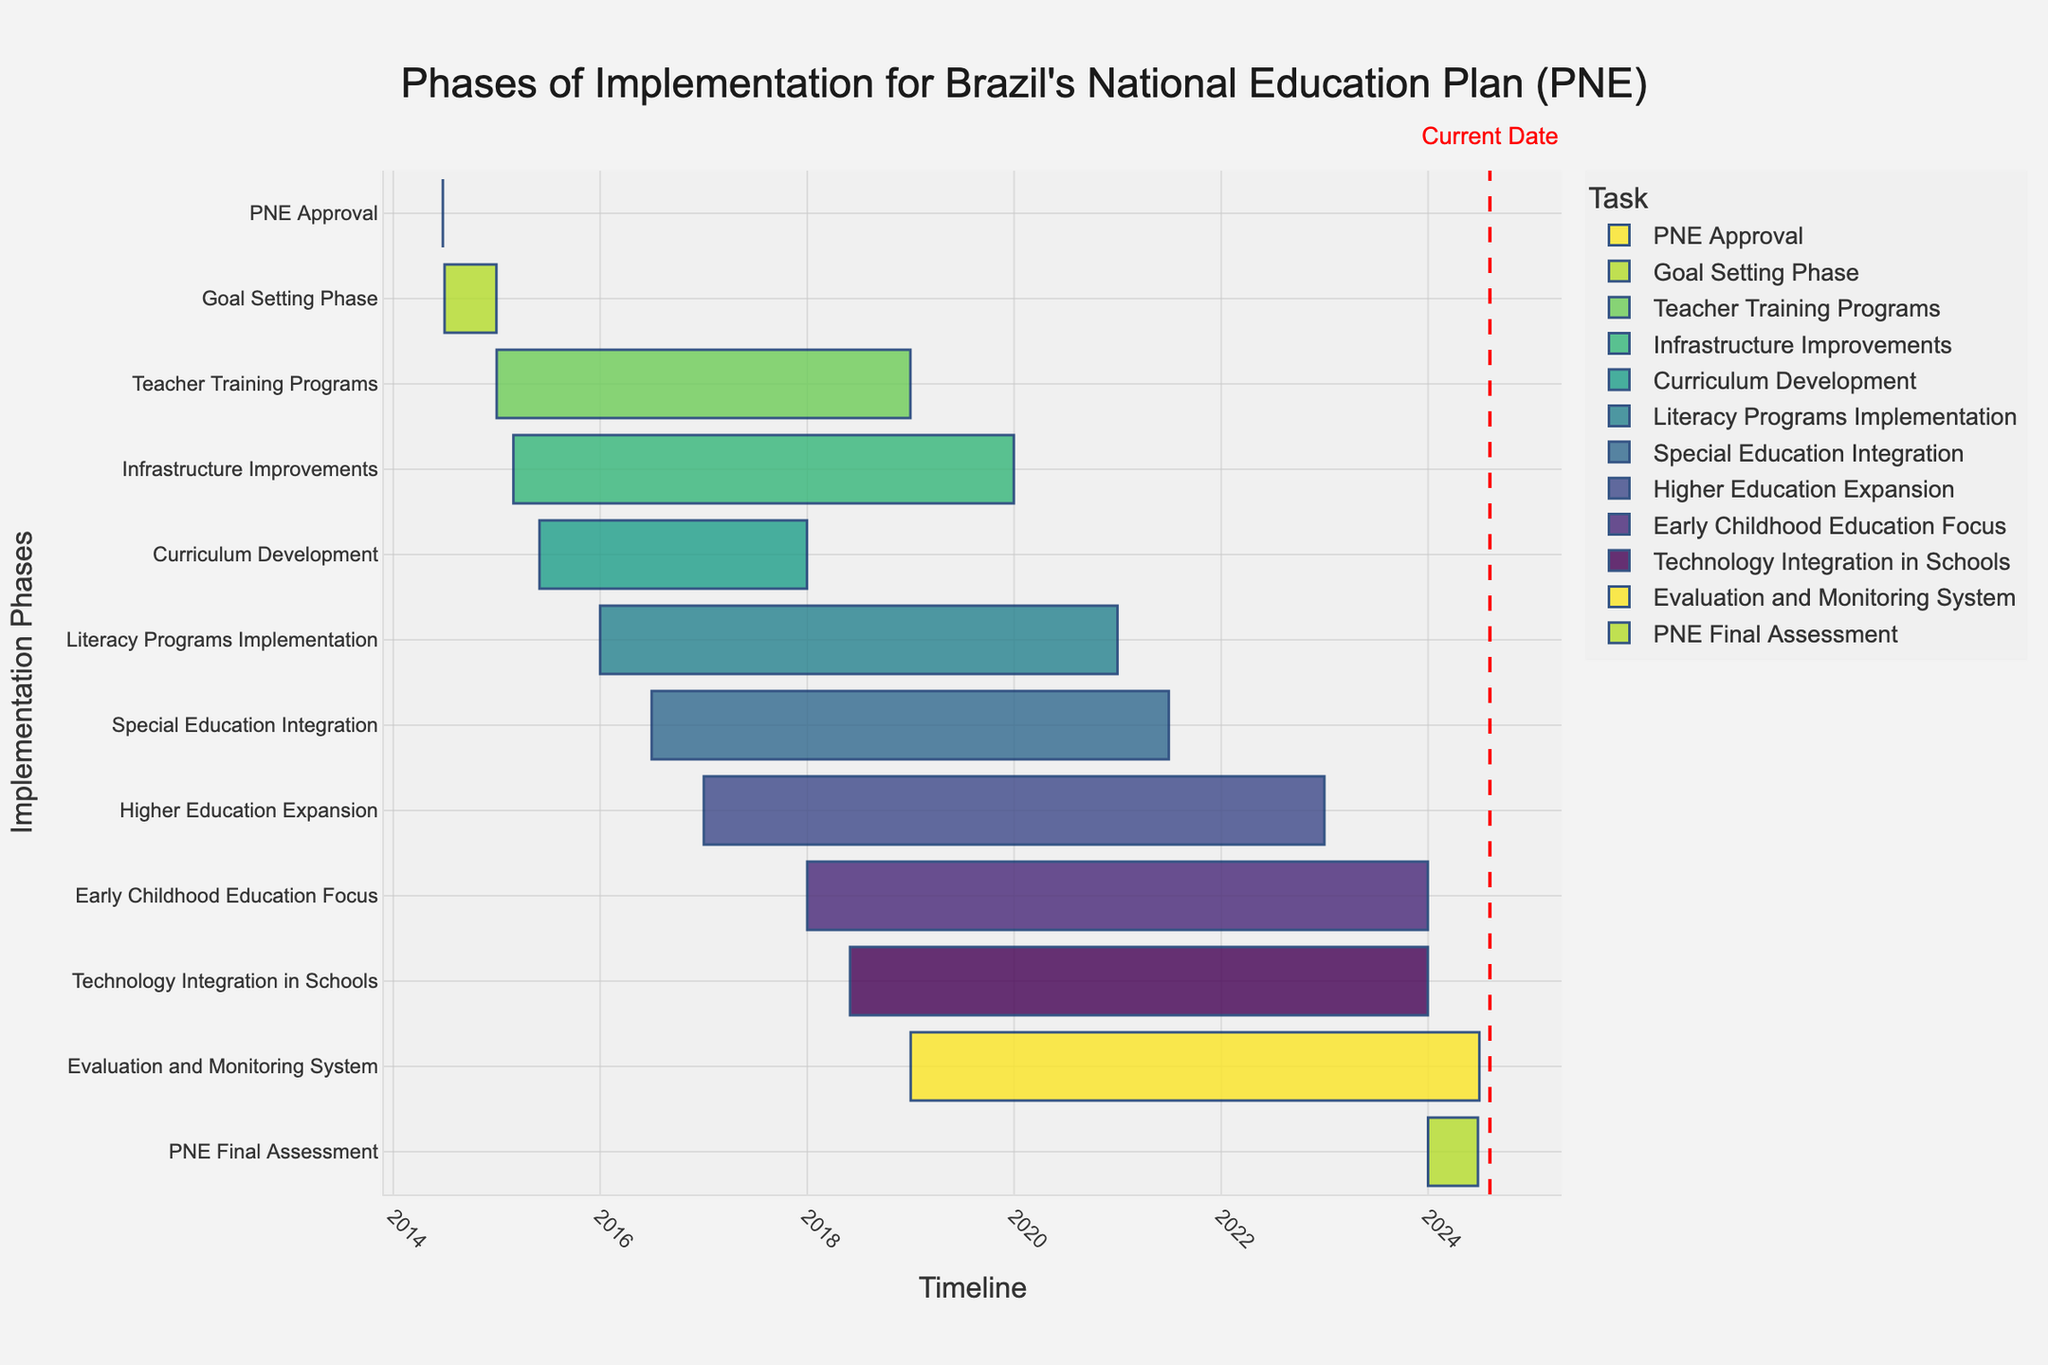Which phase starts first after the PNE approval? According to the timeline, the first phase that starts after the PNE approval is the "Goal Setting Phase," which begins on July 1, 2014.
Answer: Goal Setting Phase What is the duration of the Teacher Training Programs phase? The Teacher Training Programs phase starts on January 1, 2015, and ends on December 31, 2018. To find the duration, count the number of years from the start date to the end date. There are 4 years total.
Answer: 4 years Which phase ends last among all the implementation phases? To determine this, look for the phase that has the latest end date. The last phase to end is the "Evaluation and Monitoring System," which ends on June 30, 2024.
Answer: Evaluation and Monitoring System What is the overlap period between the Infrastructure Improvements and the Literacy Programs Implementation phases? The Infrastructure Improvements phase runs from March 1, 2015, to December 31, 2019, while the Literacy Programs Implementation phase runs from January 1, 2016, to December 31, 2020. The overlap period starts from January 1, 2016, and ends on December 31, 2019.
Answer: January 1, 2016, to December 31, 2019 How long does the Curriculum Development phase last? The Curriculum Development phase starts on June 1, 2015, and ends on December 31, 2017. To find the duration, count the number of years and months between these dates. It lasts for 2 years and 7 months.
Answer: 2 years and 7 months Between which years do most phases overlap? To determine this, examine the start and end dates of all phases. Most phases overlap between 2018 and 2019, as more than five phases are active during this period.
Answer: 2018-2019 Which phase is immediately after the Curriculum Development phase in terms of starting time? The phase that starts immediately after Curriculum Development (June 1, 2015 - December 31, 2017) is the Literacy Programs Implementation phase, starting on January 1, 2016. Although there is an overlap, Literacy Programs Implementation starts while Curriculum Development is still ongoing.
Answer: Literacy Programs Implementation Compare the starting time of Higher Education Expansion and Technology Integration in Schools phases; which one starts later? Higher Education Expansion starts on January 1, 2017, while Technology Integration in Schools starts on June 1, 2018. Therefore, Technology Integration in Schools starts later.
Answer: Technology Integration in Schools What is the last phase before the PNE Final Assessment phase? The last phase before the PNE Final Assessment, which starts on January 1, 2024, is the "Evaluation and Monitoring System," which ends on June 30, 2024, overlapping with the start of the final assessment.
Answer: Evaluation and Monitoring System 